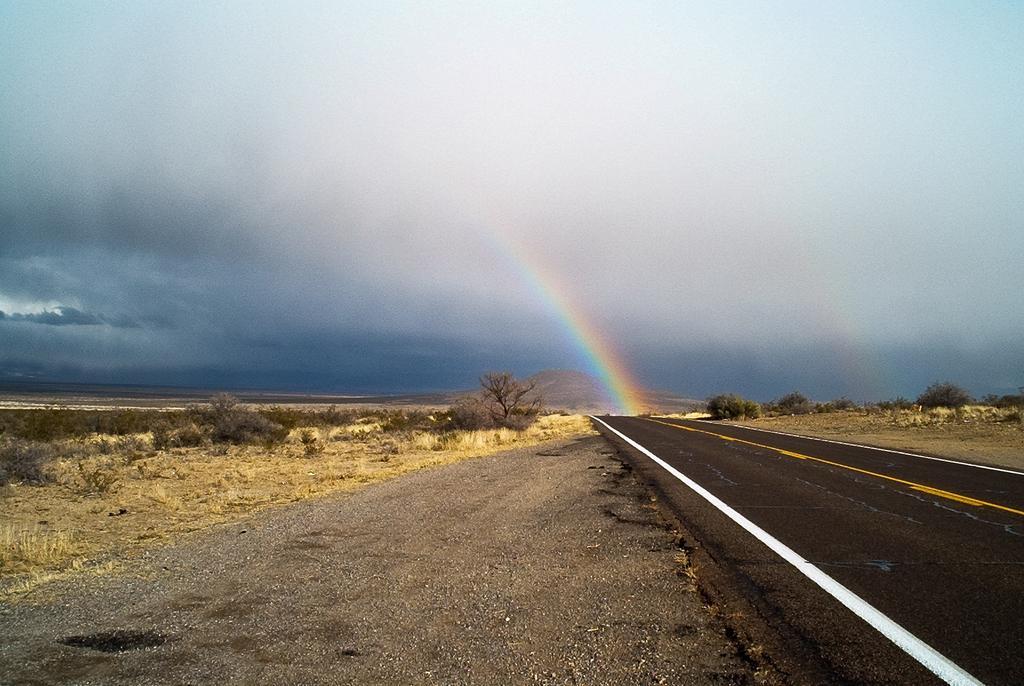In one or two sentences, can you explain what this image depicts? In this image we can see a road. Also there are trees. In the background there is sky with clouds. Also there is rainbow and there is a hill. 